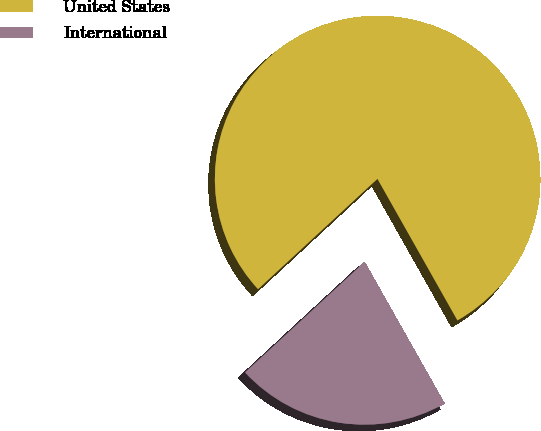Convert chart. <chart><loc_0><loc_0><loc_500><loc_500><pie_chart><fcel>United States<fcel>International<nl><fcel>78.69%<fcel>21.31%<nl></chart> 